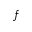<formula> <loc_0><loc_0><loc_500><loc_500>f</formula> 